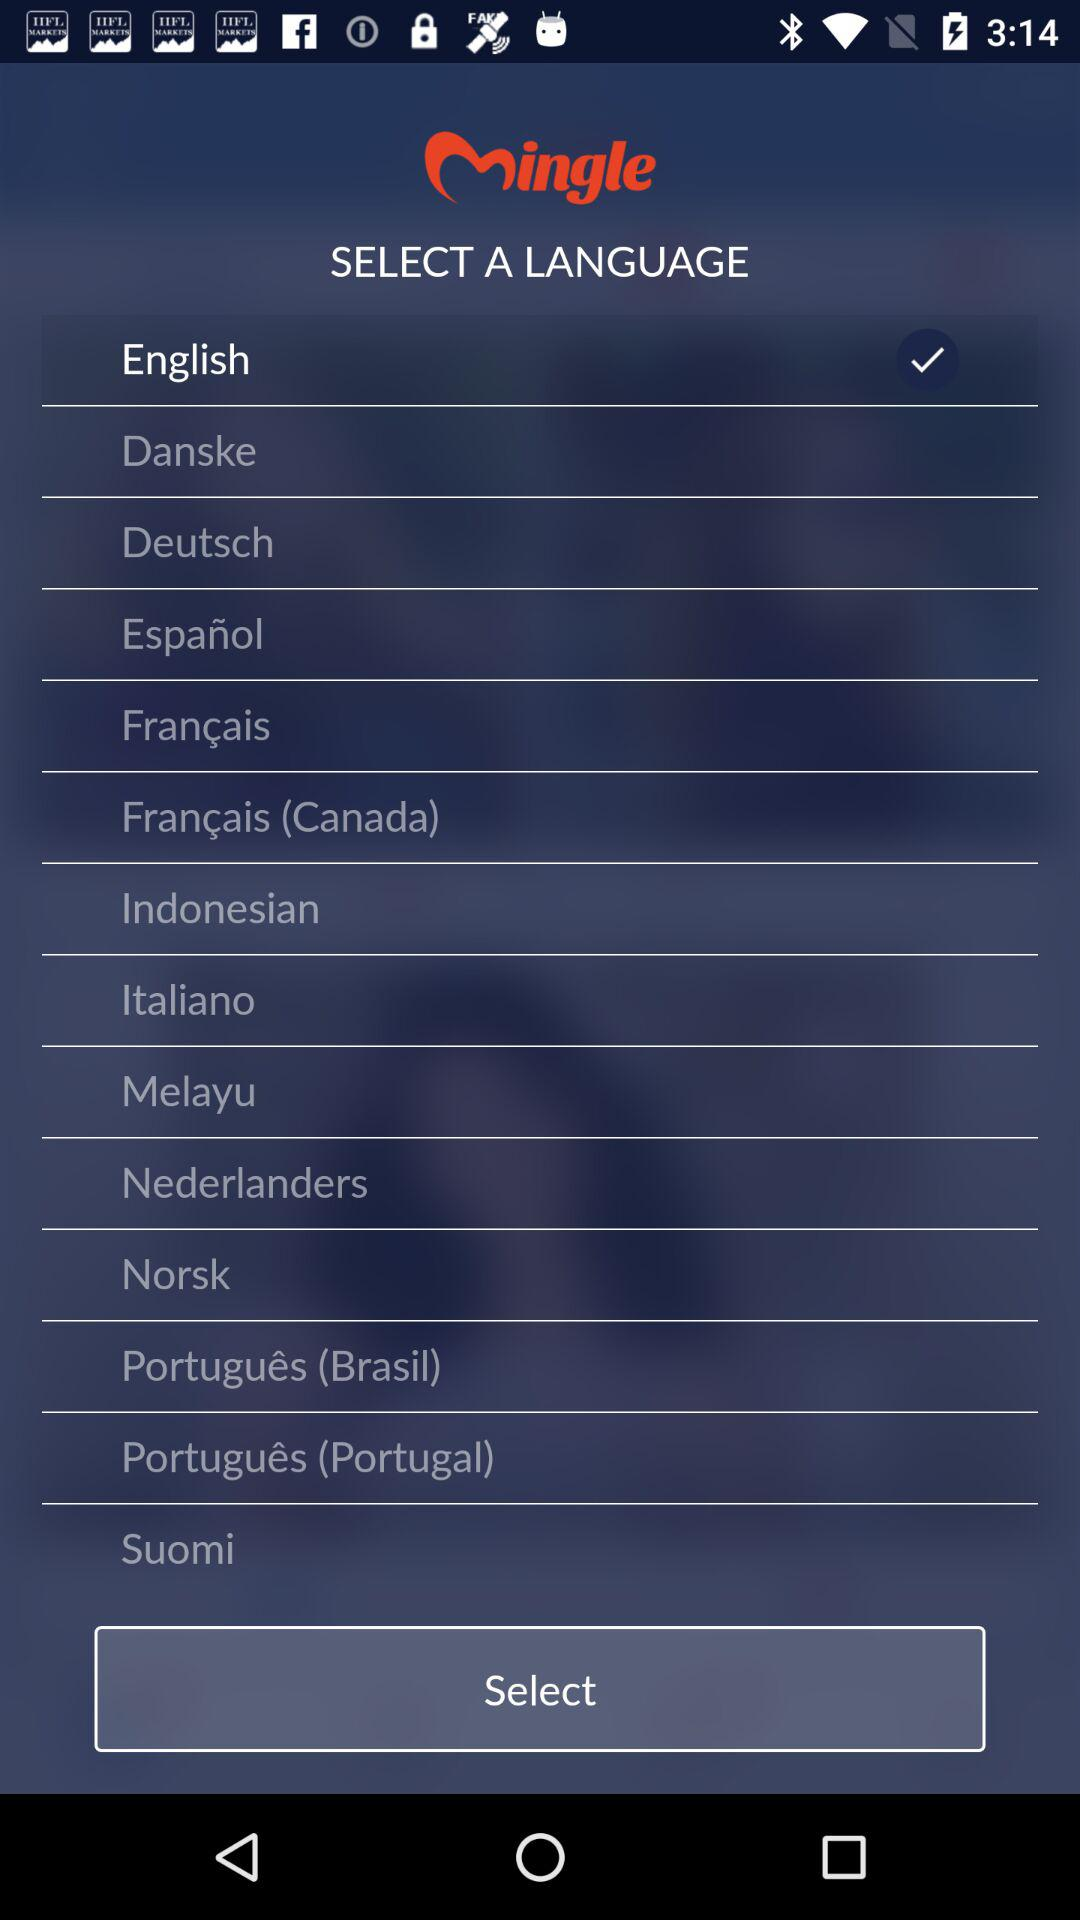Which language is selected? The selected language is English. 